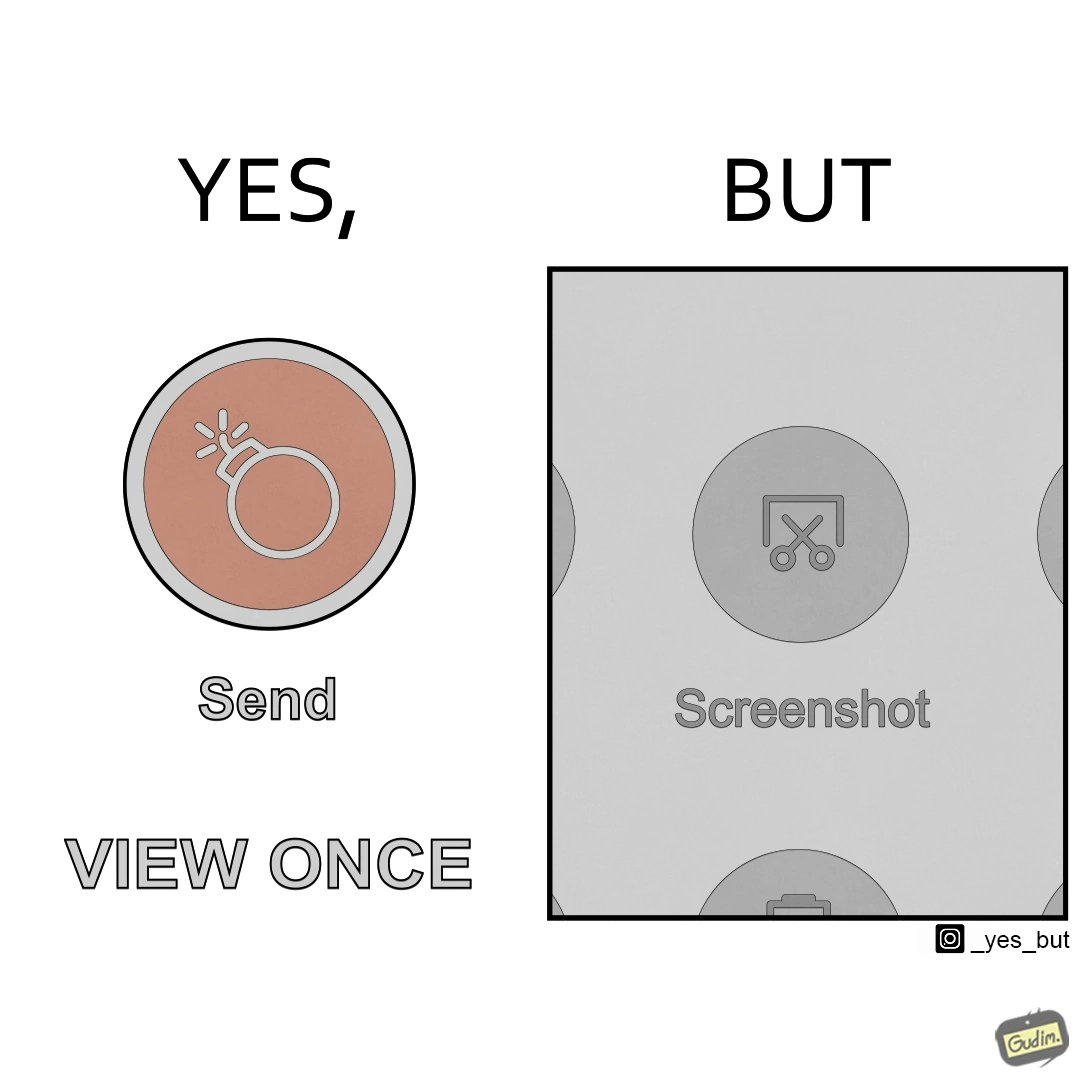What is shown in this image? The images are funny since it shows how useless a 'view only once' option is for a sender since the recipient can just take a screenshot of the sent image and view it as many times as he/she wants 